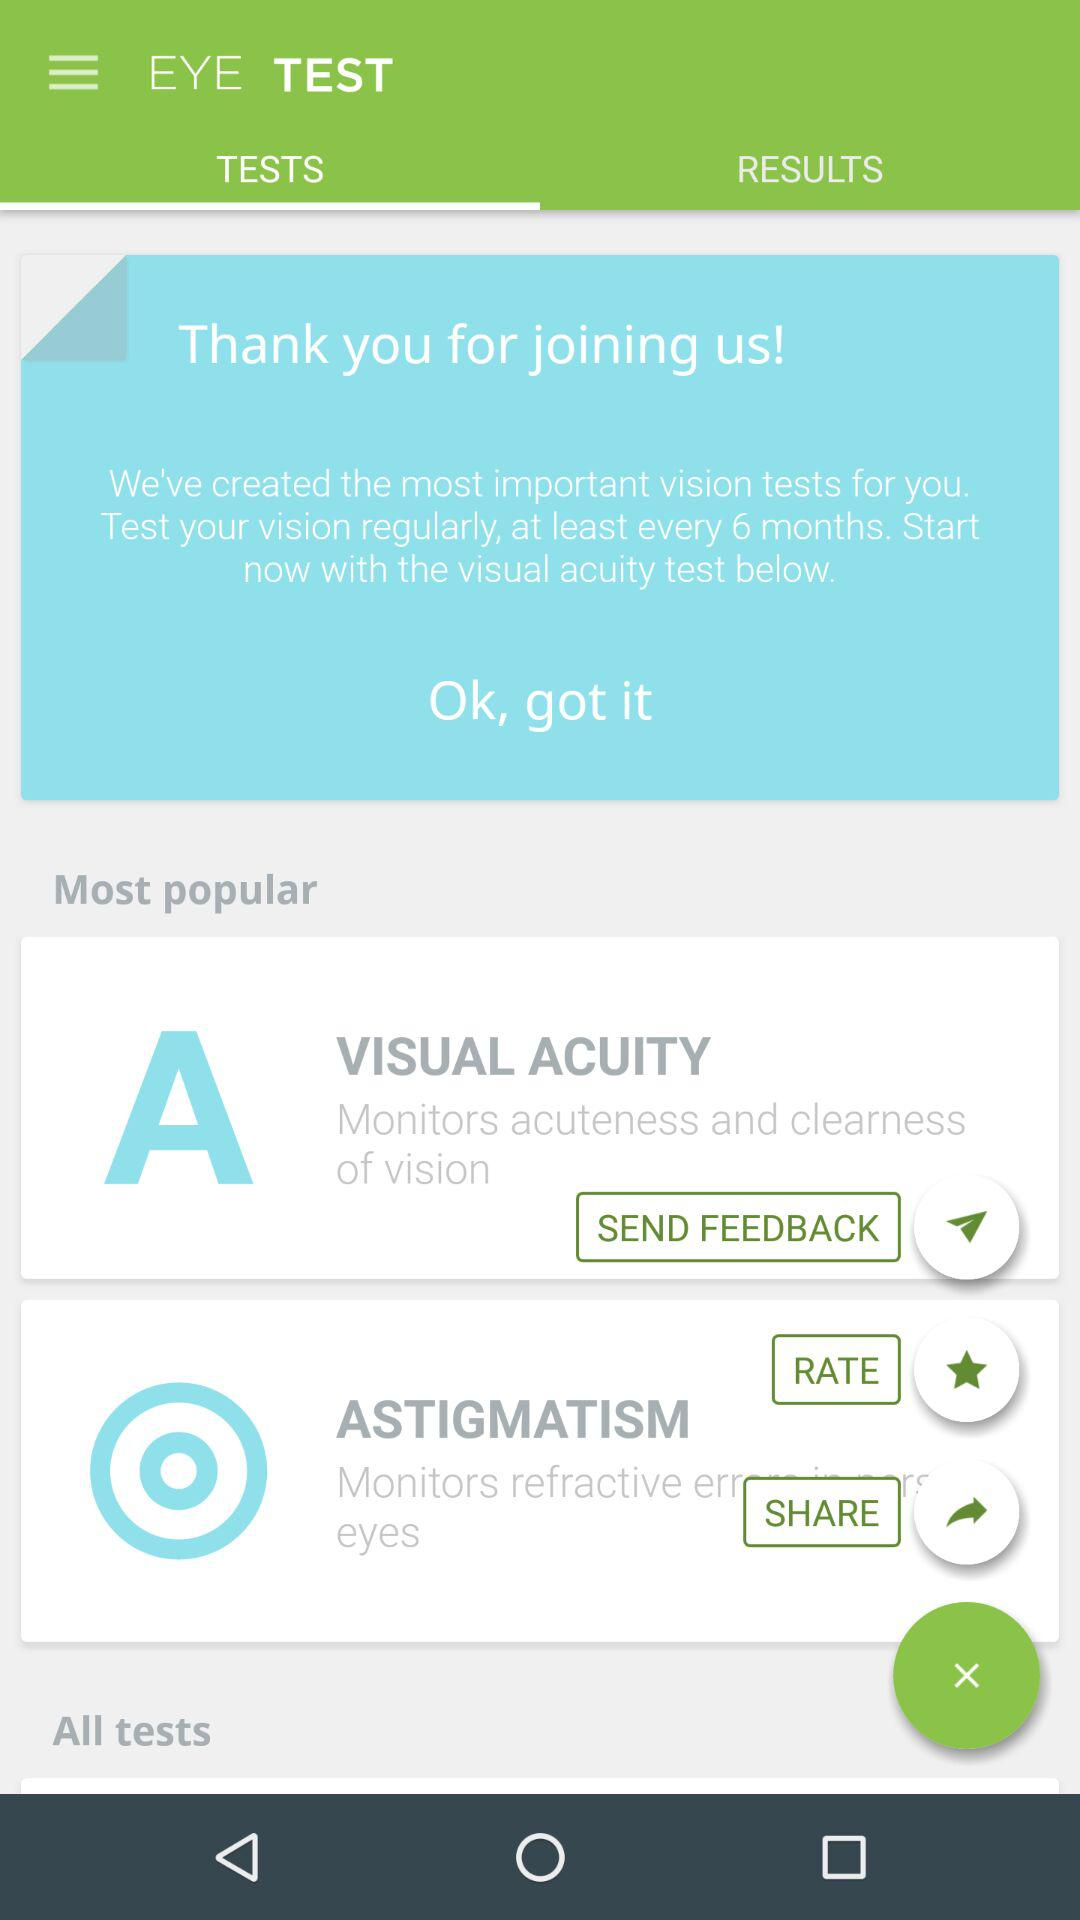Which tab is selected? The selected tab is "TESTS". 